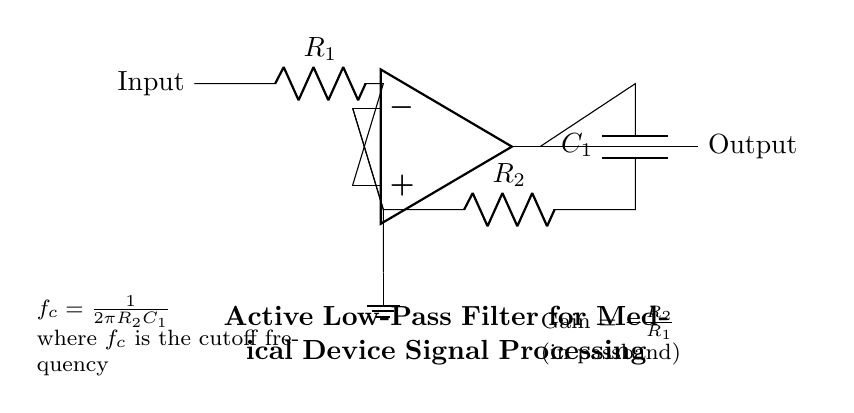What type of filter is represented in the circuit? The circuit is labeled as an active low-pass filter, indicating it allows low-frequency signals to pass while attenuating high-frequency signals.
Answer: active low-pass filter What components are used in this active filter circuit? The circuit contains two resistors, R1 and R2, one capacitor C1, and an operational amplifier. These components are standard in active filter circuitry.
Answer: R1, R2, C1, op-amp What is the cutoff frequency formula for this filter? The cutoff frequency formula is given as f_c = 1/(2πR2C1), indicating the relationship between resistance, capacitance, and frequency in the circuit.
Answer: f_c = 1/(2πR2C1) What does the gain represent in this circuit? The gain is defined as -R2/R1 in the passband, which indicates how much the output signal is amplified relative to the input signal within the frequency range where the filter operates effectively.
Answer: -R2/R1 What happens to signals above the cutoff frequency? Signals above the cutoff frequency are attenuated, meaning their amplitudes are reduced, as the filter is designed to block or diminish high-frequency inputs.
Answer: Attenuated How does changing R2 affect the cutoff frequency? Increasing R2 will decrease the cutoff frequency, because it is inversely proportional in the formula f_c = 1/(2πR2C1). Thus, the filter will allow lower frequencies to pass.
Answer: Decrease the cutoff frequency Why is there a ground connection in the circuit? The ground connection provides a reference point for the circuit, stabilizing the voltage levels and ensuring the operational amplifier functions correctly within a defined range.
Answer: Reference point 